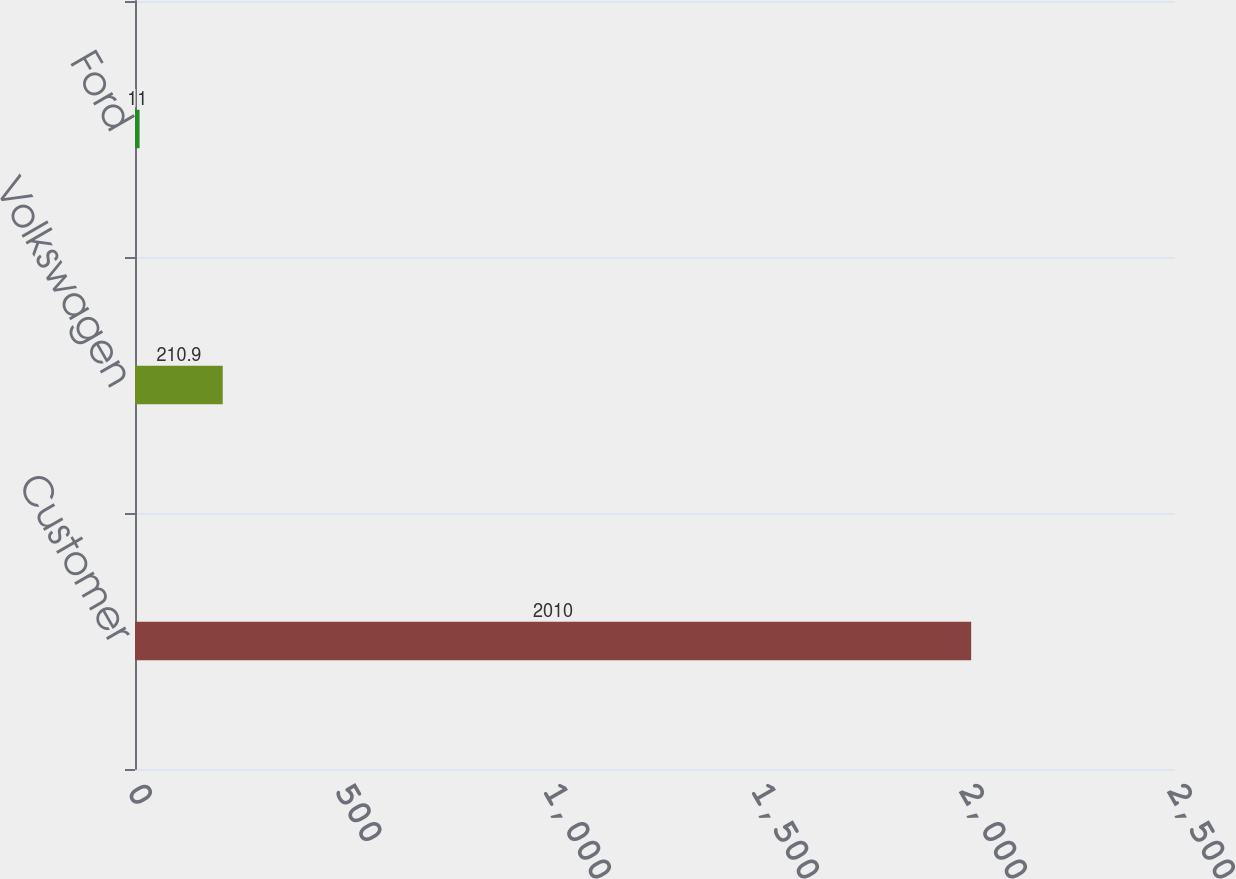Convert chart. <chart><loc_0><loc_0><loc_500><loc_500><bar_chart><fcel>Customer<fcel>Volkswagen<fcel>Ford<nl><fcel>2010<fcel>210.9<fcel>11<nl></chart> 